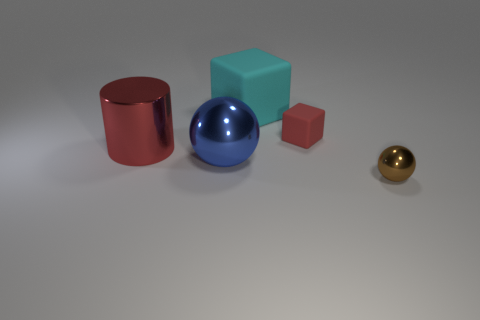Add 2 yellow metallic spheres. How many objects exist? 7 Subtract all blocks. How many objects are left? 3 Add 4 red cylinders. How many red cylinders exist? 5 Subtract 1 cyan blocks. How many objects are left? 4 Subtract all brown metallic objects. Subtract all large rubber things. How many objects are left? 3 Add 5 blue shiny things. How many blue shiny things are left? 6 